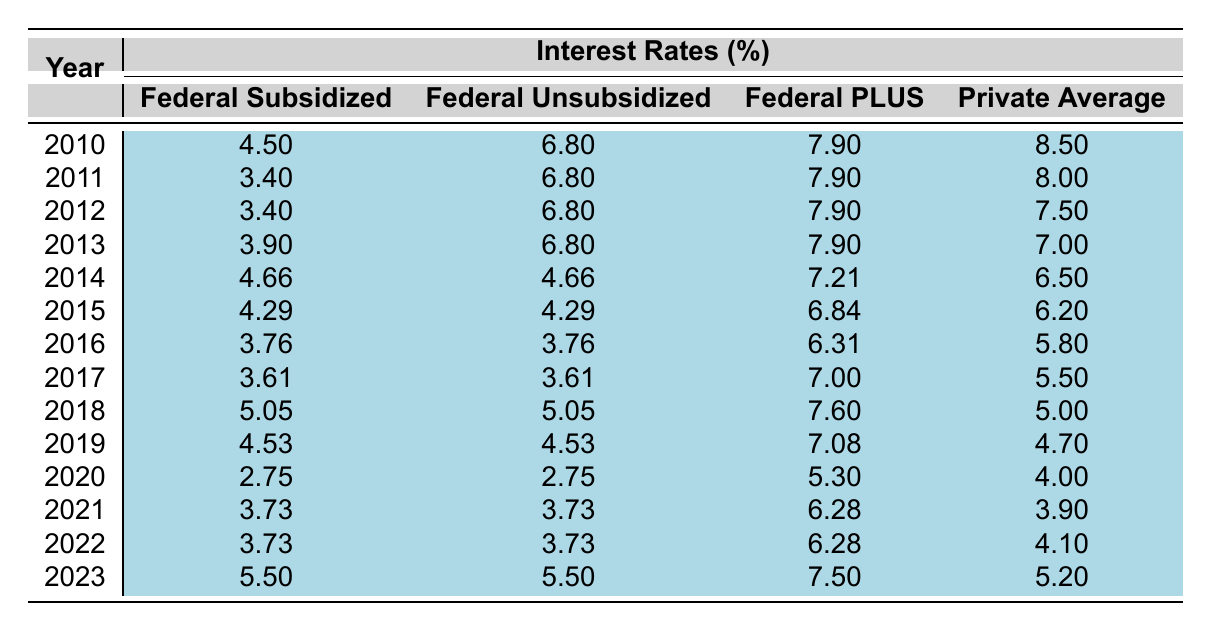What was the interest rate for Federal Subsidized Loans in 2015? In the table, the row for the year 2015 shows the interest rate for Federal Subsidized Loans as 4.29%.
Answer: 4.29% Which year had the highest interest rate for Federal PLUS Loans? By examining the Federal PLUS loan rates for each year, the highest rate is 7.90% for the years 2010, 2011, 2012, and 2013.
Answer: 7.90% What is the average interest rate for Private Loans from 2010 to 2023? Adding all the Private Loan Average rates from the years 2010 (8.5), 2011 (8.0), 2012 (7.5), 2013 (7.0), 2014 (6.5), 2015 (6.2), 2016 (5.8), 2017 (5.5), 2018 (5.0), 2019 (4.7), 2020 (4.0), 2021 (3.9), 2022 (4.1), and 2023 (5.2) gives a sum of 73.6. Dividing this by 14 (the number of years) results in an average of approximately 5.26.
Answer: 5.26 Did Federal Subsidized Loan rates decrease from 2010 to 2020? Looking at the Federal Subsidized Loan rates in 2010 (4.5%) and comparing it to 2020 (2.75%), there is a decrease.
Answer: Yes What was the trend in Federal Unsubsidized Loan rates between 2010 and 2016? Analyzing the rates: 2010 was 6.8%, and it reduced gradually to 3.76% in 2016. This indicates a decreasing trend.
Answer: Decreasing Which loan type had consistently the highest rates from 2010 to 2019? By comparing all loan types across the years, the Private Loan Average had the highest interest rates compared to other categories, peaking at 8.5% in 2010.
Answer: Private Loan Average What was the difference between the highest and lowest Federal Subsidized Loan interest rates between 2010 and 2023? The highest rate for Federal Subsidized Loans in this period was 5.5% in 2023, while the lowest was 2.75% in 2020. The difference is 5.5 - 2.75 = 2.75.
Answer: 2.75 Which year had an interest rate of 5.05% for Federal Subsidized Loans? The table shows that the year 2018 had an interest rate of 5.05% for Federal Subsidized Loans.
Answer: 2018 What percentage did Private Loan averages fall from 2010 to 2023? The Private Loan Average was 8.5% in 2010 and 5.2% in 2023. To find the percentage decrease, calculate (8.5 - 5.2) / 8.5 * 100 which equals approximately 38.82%.
Answer: 38.82% In which three years did the Federal Unsubsidized Loan rates remain stable at 6.8%? The Federal Unsubsidized Loan rate of 6.8% is stable for the years 2010, 2011, 2012, and 2013. Therefore, the three specified years could be 2010, 2011, and 2012.
Answer: 2010, 2011, 2012 